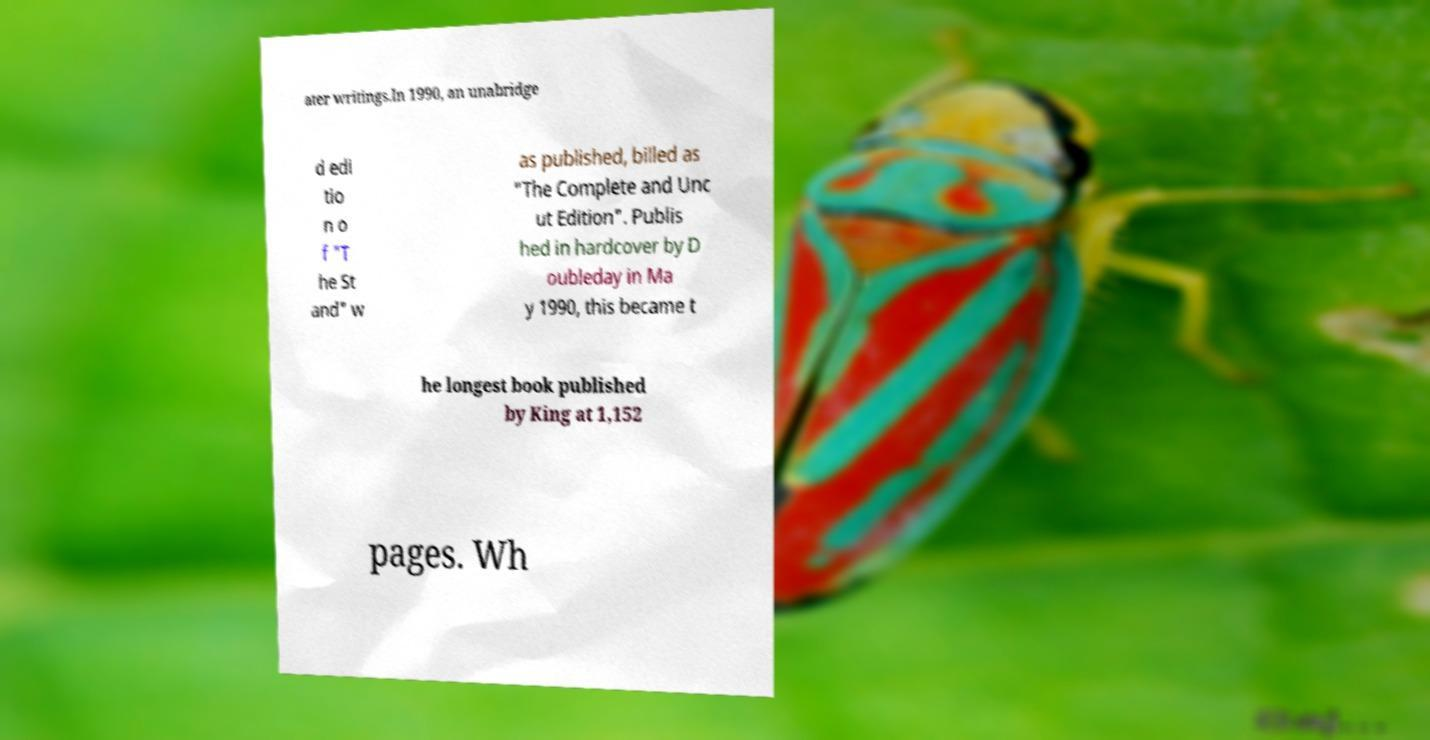Can you accurately transcribe the text from the provided image for me? ater writings.In 1990, an unabridge d edi tio n o f "T he St and" w as published, billed as "The Complete and Unc ut Edition". Publis hed in hardcover by D oubleday in Ma y 1990, this became t he longest book published by King at 1,152 pages. Wh 